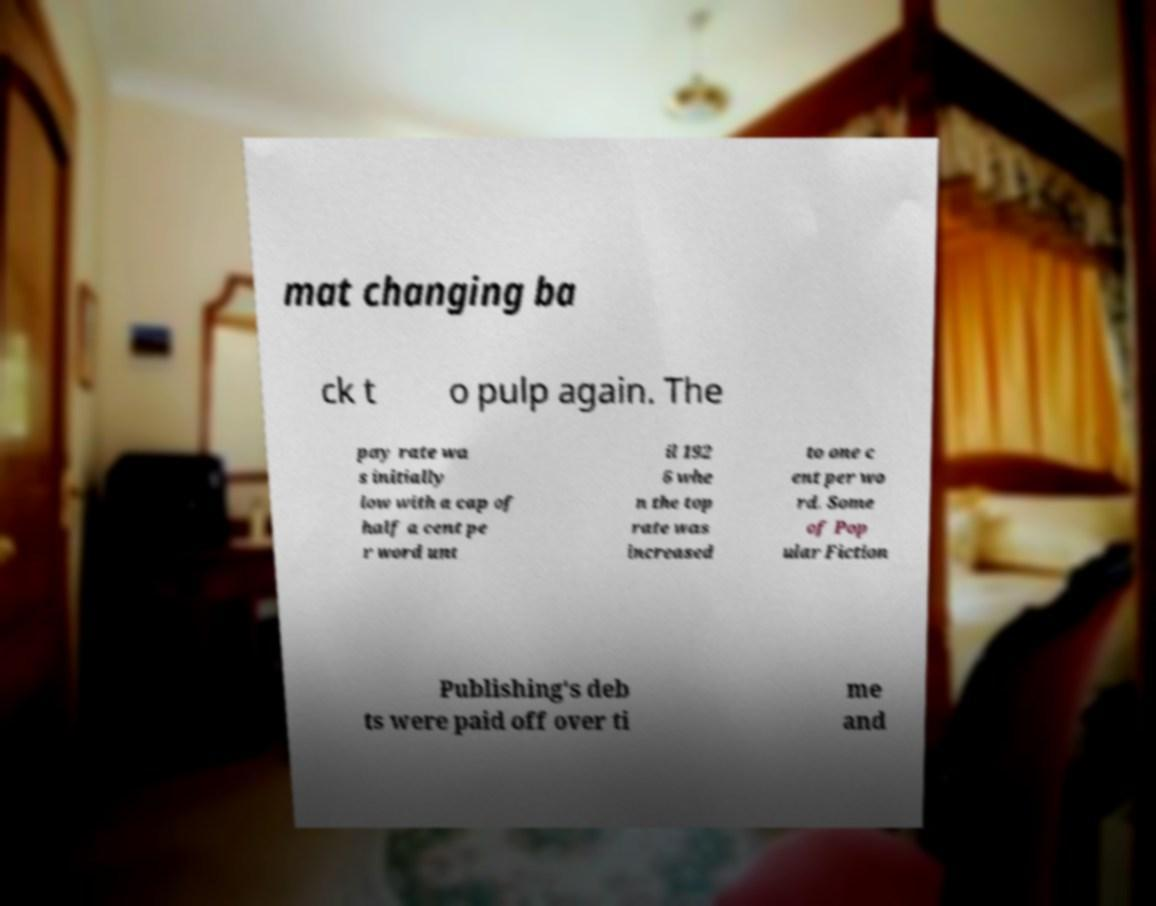Could you extract and type out the text from this image? mat changing ba ck t o pulp again. The pay rate wa s initially low with a cap of half a cent pe r word unt il 192 6 whe n the top rate was increased to one c ent per wo rd. Some of Pop ular Fiction Publishing's deb ts were paid off over ti me and 